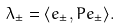Convert formula to latex. <formula><loc_0><loc_0><loc_500><loc_500>\lambda _ { \pm } = \langle e _ { \pm } , P e _ { \pm } \rangle .</formula> 